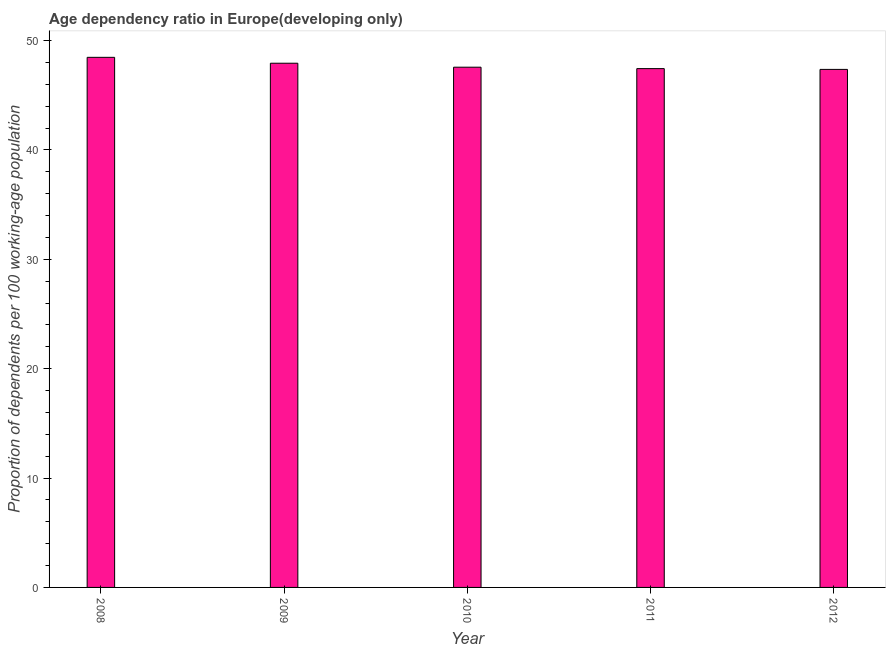Does the graph contain grids?
Provide a succinct answer. No. What is the title of the graph?
Ensure brevity in your answer.  Age dependency ratio in Europe(developing only). What is the label or title of the X-axis?
Offer a very short reply. Year. What is the label or title of the Y-axis?
Offer a terse response. Proportion of dependents per 100 working-age population. What is the age dependency ratio in 2010?
Your response must be concise. 47.57. Across all years, what is the maximum age dependency ratio?
Your response must be concise. 48.47. Across all years, what is the minimum age dependency ratio?
Ensure brevity in your answer.  47.37. In which year was the age dependency ratio maximum?
Offer a terse response. 2008. In which year was the age dependency ratio minimum?
Keep it short and to the point. 2012. What is the sum of the age dependency ratio?
Offer a terse response. 238.78. What is the difference between the age dependency ratio in 2010 and 2012?
Your response must be concise. 0.2. What is the average age dependency ratio per year?
Give a very brief answer. 47.76. What is the median age dependency ratio?
Give a very brief answer. 47.57. In how many years, is the age dependency ratio greater than 44 ?
Ensure brevity in your answer.  5. Do a majority of the years between 2008 and 2010 (inclusive) have age dependency ratio greater than 6 ?
Your answer should be compact. Yes. What is the ratio of the age dependency ratio in 2008 to that in 2012?
Ensure brevity in your answer.  1.02. Is the age dependency ratio in 2009 less than that in 2010?
Provide a short and direct response. No. What is the difference between the highest and the second highest age dependency ratio?
Your answer should be very brief. 0.54. Is the sum of the age dependency ratio in 2010 and 2011 greater than the maximum age dependency ratio across all years?
Provide a short and direct response. Yes. What is the difference between the highest and the lowest age dependency ratio?
Make the answer very short. 1.1. How many bars are there?
Your answer should be very brief. 5. Are all the bars in the graph horizontal?
Ensure brevity in your answer.  No. What is the difference between two consecutive major ticks on the Y-axis?
Your answer should be compact. 10. What is the Proportion of dependents per 100 working-age population in 2008?
Keep it short and to the point. 48.47. What is the Proportion of dependents per 100 working-age population of 2009?
Offer a very short reply. 47.93. What is the Proportion of dependents per 100 working-age population in 2010?
Give a very brief answer. 47.57. What is the Proportion of dependents per 100 working-age population of 2011?
Provide a succinct answer. 47.44. What is the Proportion of dependents per 100 working-age population in 2012?
Ensure brevity in your answer.  47.37. What is the difference between the Proportion of dependents per 100 working-age population in 2008 and 2009?
Make the answer very short. 0.54. What is the difference between the Proportion of dependents per 100 working-age population in 2008 and 2010?
Give a very brief answer. 0.9. What is the difference between the Proportion of dependents per 100 working-age population in 2008 and 2011?
Provide a short and direct response. 1.03. What is the difference between the Proportion of dependents per 100 working-age population in 2008 and 2012?
Offer a very short reply. 1.1. What is the difference between the Proportion of dependents per 100 working-age population in 2009 and 2010?
Provide a succinct answer. 0.36. What is the difference between the Proportion of dependents per 100 working-age population in 2009 and 2011?
Provide a succinct answer. 0.49. What is the difference between the Proportion of dependents per 100 working-age population in 2009 and 2012?
Make the answer very short. 0.56. What is the difference between the Proportion of dependents per 100 working-age population in 2010 and 2011?
Ensure brevity in your answer.  0.13. What is the difference between the Proportion of dependents per 100 working-age population in 2010 and 2012?
Keep it short and to the point. 0.2. What is the difference between the Proportion of dependents per 100 working-age population in 2011 and 2012?
Give a very brief answer. 0.07. What is the ratio of the Proportion of dependents per 100 working-age population in 2008 to that in 2009?
Ensure brevity in your answer.  1.01. What is the ratio of the Proportion of dependents per 100 working-age population in 2008 to that in 2010?
Offer a terse response. 1.02. What is the ratio of the Proportion of dependents per 100 working-age population in 2009 to that in 2011?
Make the answer very short. 1.01. What is the ratio of the Proportion of dependents per 100 working-age population in 2009 to that in 2012?
Keep it short and to the point. 1.01. What is the ratio of the Proportion of dependents per 100 working-age population in 2011 to that in 2012?
Make the answer very short. 1. 